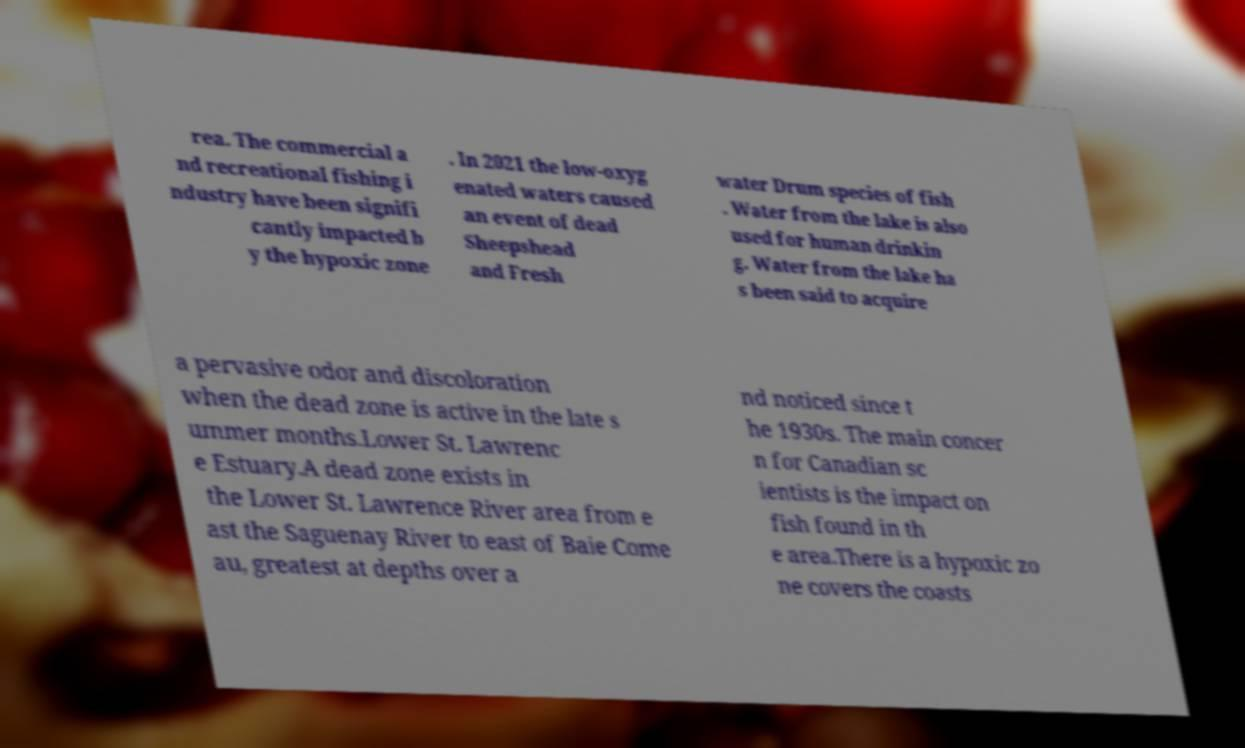Could you assist in decoding the text presented in this image and type it out clearly? rea. The commercial a nd recreational fishing i ndustry have been signifi cantly impacted b y the hypoxic zone . In 2021 the low-oxyg enated waters caused an event of dead Sheepshead and Fresh water Drum species of fish . Water from the lake is also used for human drinkin g. Water from the lake ha s been said to acquire a pervasive odor and discoloration when the dead zone is active in the late s ummer months.Lower St. Lawrenc e Estuary.A dead zone exists in the Lower St. Lawrence River area from e ast the Saguenay River to east of Baie Come au, greatest at depths over a nd noticed since t he 1930s. The main concer n for Canadian sc ientists is the impact on fish found in th e area.There is a hypoxic zo ne covers the coasts 